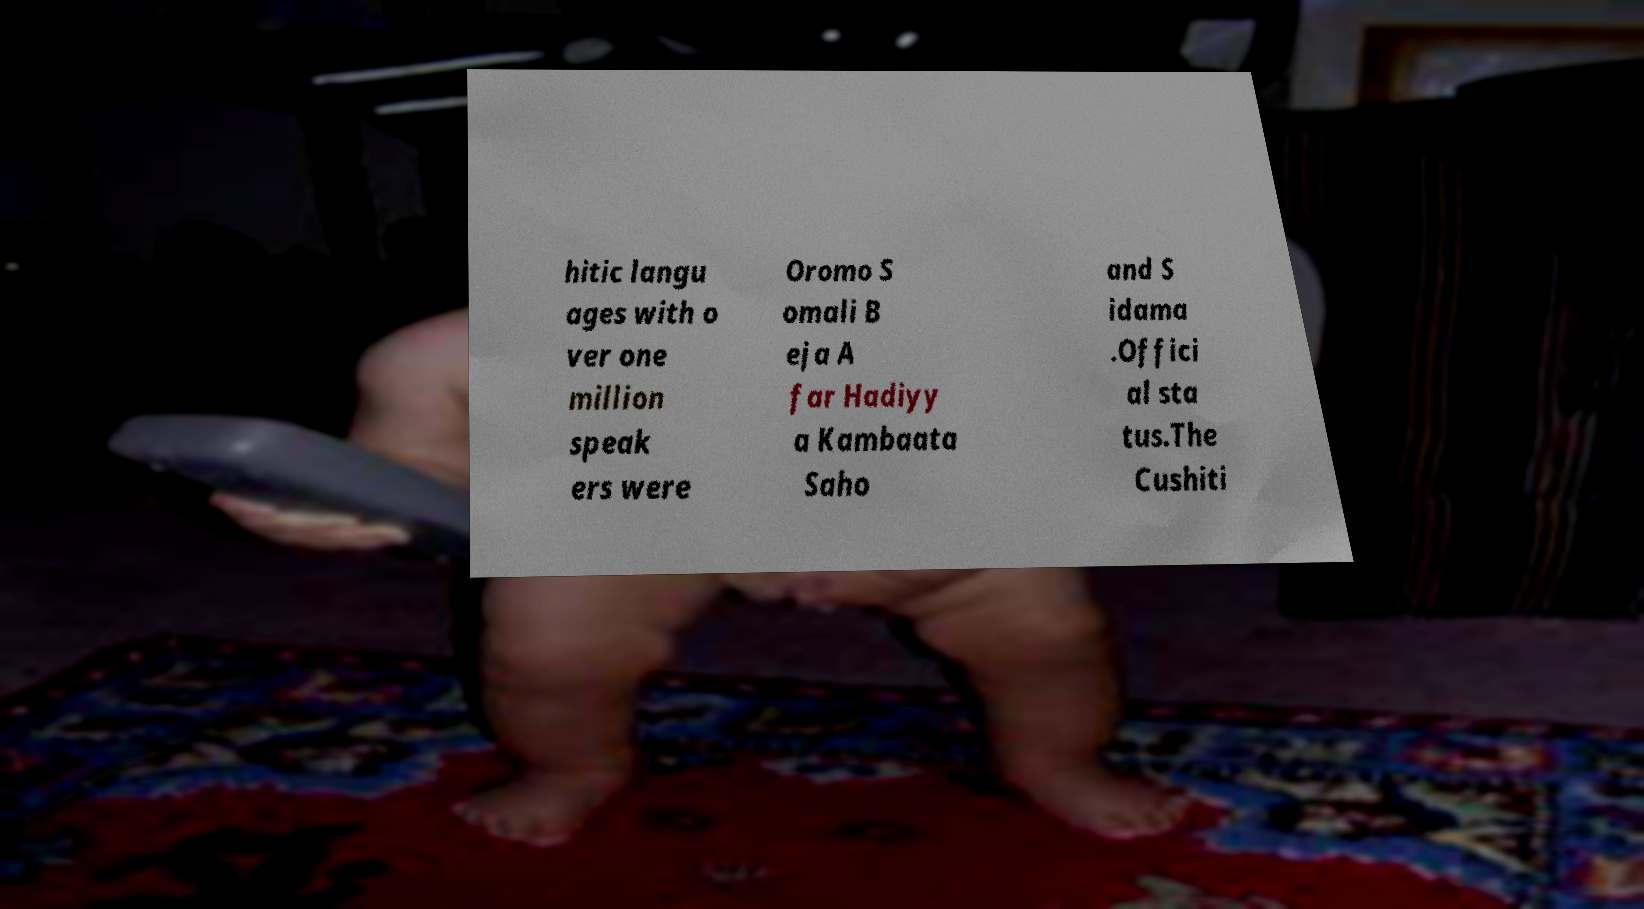Please read and relay the text visible in this image. What does it say? hitic langu ages with o ver one million speak ers were Oromo S omali B eja A far Hadiyy a Kambaata Saho and S idama .Offici al sta tus.The Cushiti 